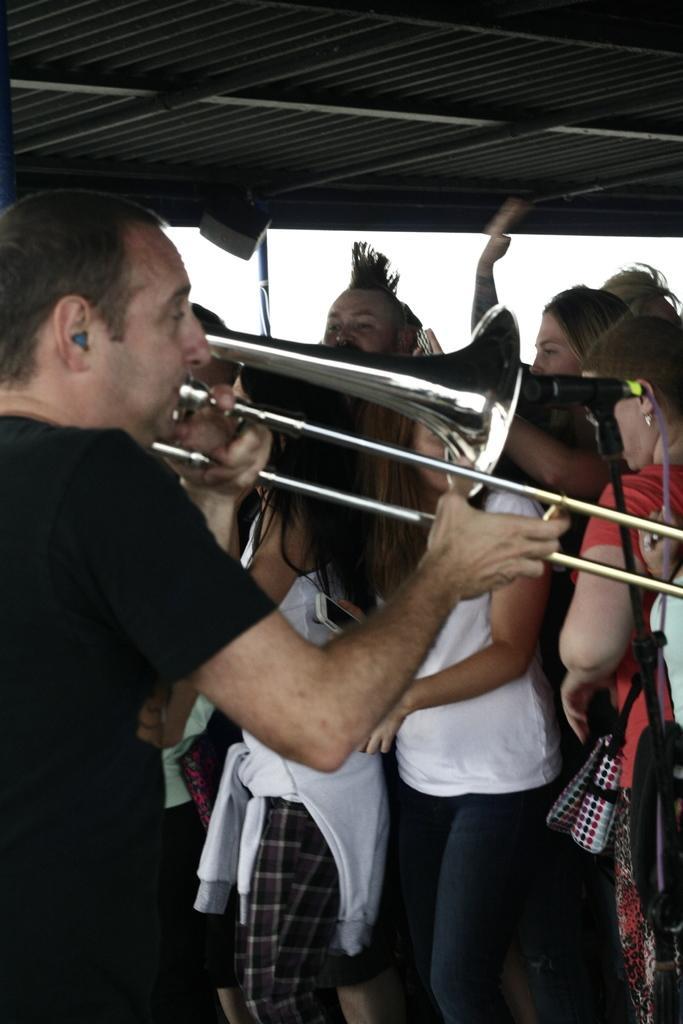In one or two sentences, can you explain what this image depicts? In the center of the image there is a person holding a musical instrument. He is wearing a black color t-shirt. At the background of the image there are many people. At the top of the image there is a roof. 